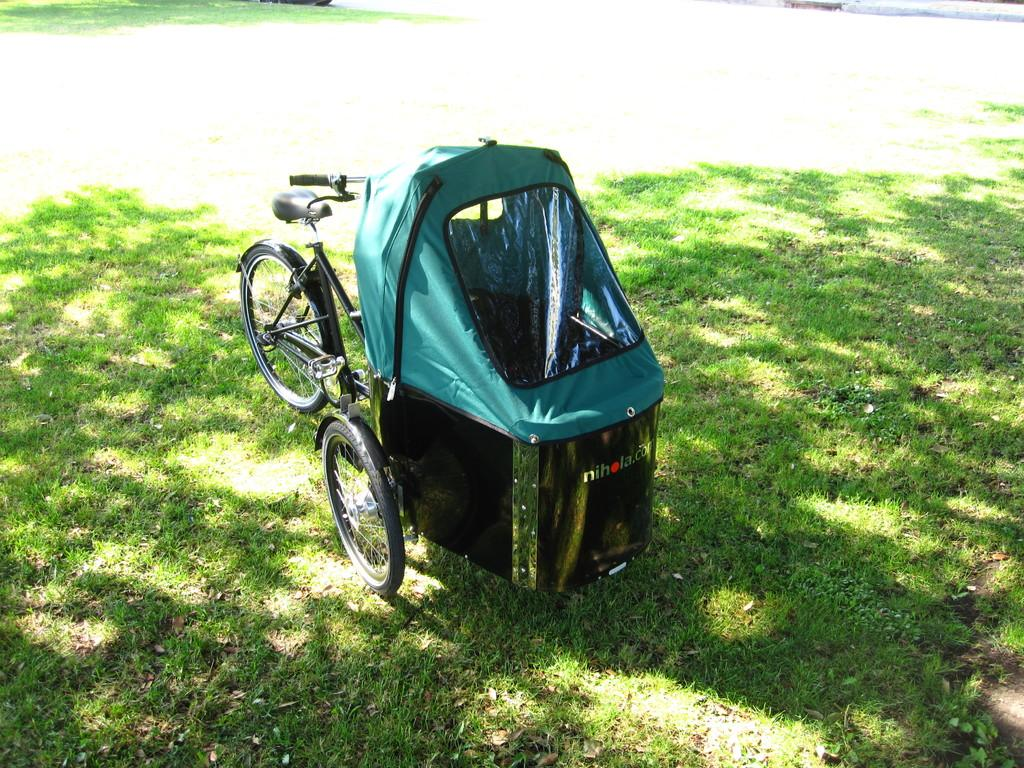What is the main object in the image? There is a trolley in the image. Where is the trolley located? The trolley is on the ground. How is the trolley positioned in the image? The trolley is in the center of the image. Reasoning: Let's think step by step by step in order to produce the conversation. We start by identifying the main object in the image, which is the trolley. Then, we describe its location and position, providing specific details about where it is and how it is situated in the image. Each question is designed to elicit a specific detail about the image that is known from the provided facts. Absurd Question/Answer: What type of dirt can be seen on the trolley in the image? There is no dirt visible on the trolley in the image. Is there a fire hydrant next to the trolley in the image? There is no fire hydrant present in the image. How many steps are there on the trolley in the image? There are no steps visible on the trolley in the image. 